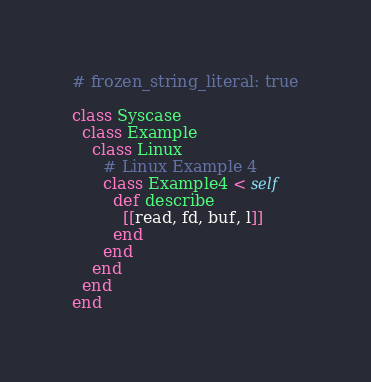Convert code to text. <code><loc_0><loc_0><loc_500><loc_500><_Ruby_># frozen_string_literal: true

class Syscase
  class Example
    class Linux
      # Linux Example 4
      class Example4 < self
        def describe
          [[read, fd, buf, l]]
        end
      end
    end
  end
end
</code> 